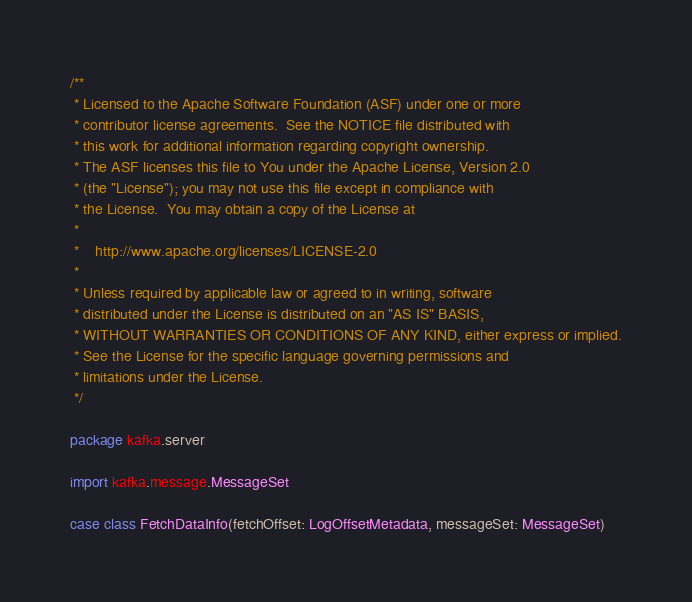<code> <loc_0><loc_0><loc_500><loc_500><_Scala_>/**
 * Licensed to the Apache Software Foundation (ASF) under one or more
 * contributor license agreements.  See the NOTICE file distributed with
 * this work for additional information regarding copyright ownership.
 * The ASF licenses this file to You under the Apache License, Version 2.0
 * (the "License"); you may not use this file except in compliance with
 * the License.  You may obtain a copy of the License at
 *
 *    http://www.apache.org/licenses/LICENSE-2.0
 *
 * Unless required by applicable law or agreed to in writing, software
 * distributed under the License is distributed on an "AS IS" BASIS,
 * WITHOUT WARRANTIES OR CONDITIONS OF ANY KIND, either express or implied.
 * See the License for the specific language governing permissions and
 * limitations under the License.
 */

package kafka.server

import kafka.message.MessageSet

case class FetchDataInfo(fetchOffset: LogOffsetMetadata, messageSet: MessageSet)
</code> 